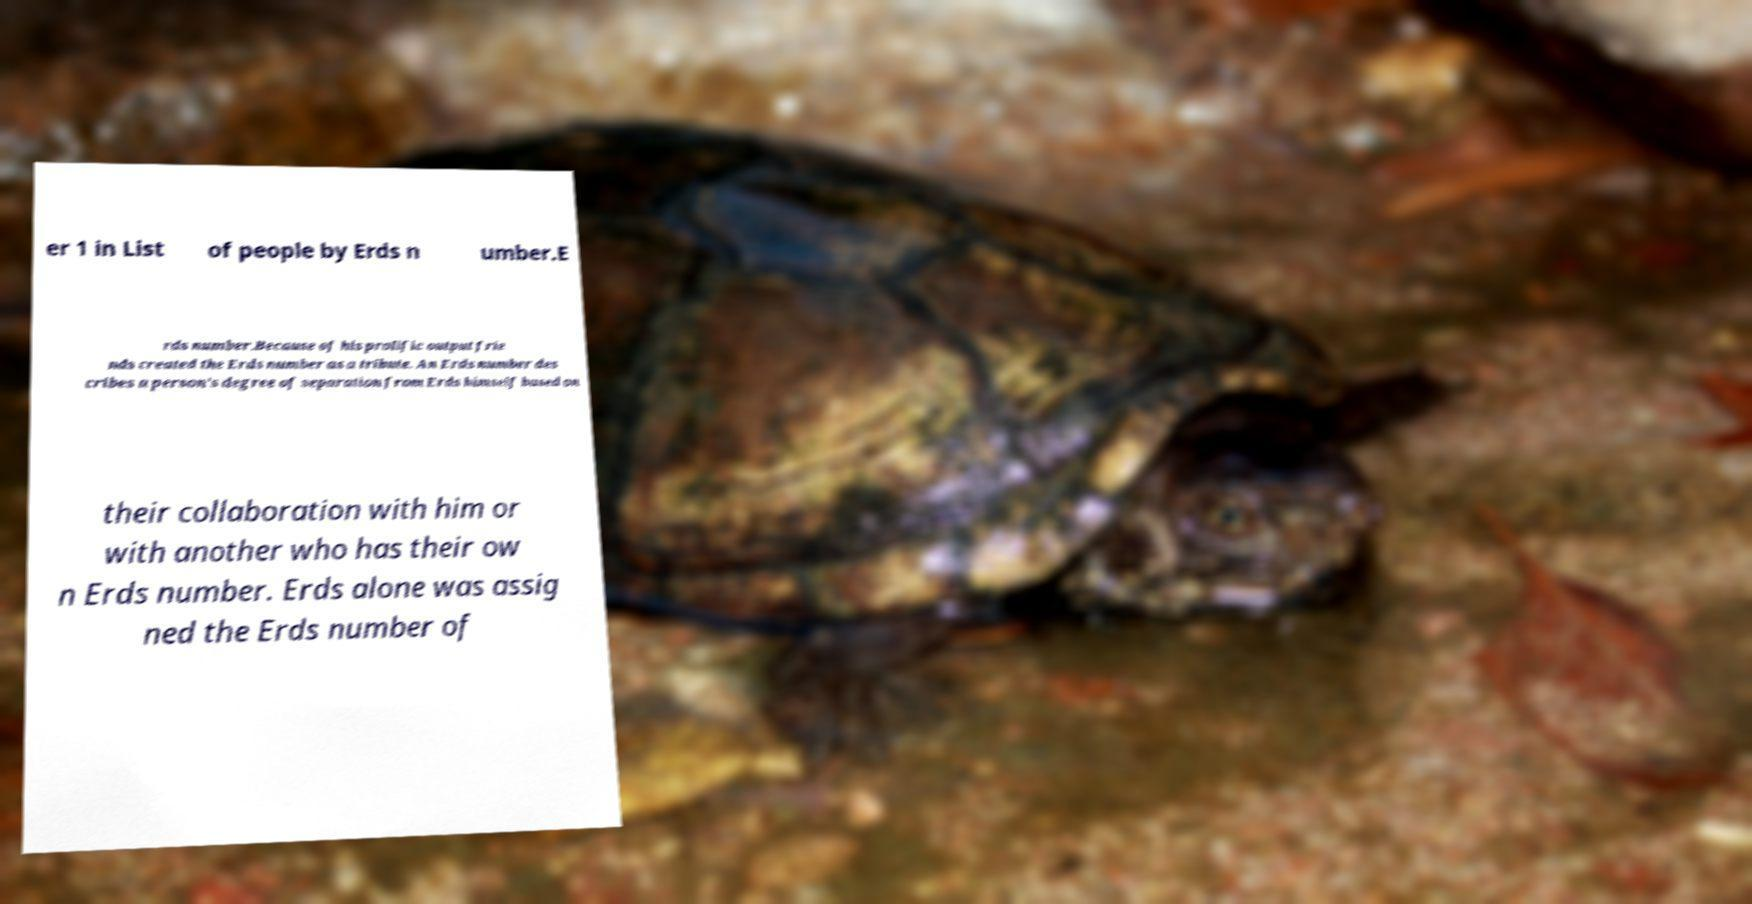I need the written content from this picture converted into text. Can you do that? er 1 in List of people by Erds n umber.E rds number.Because of his prolific output frie nds created the Erds number as a tribute. An Erds number des cribes a person's degree of separation from Erds himself based on their collaboration with him or with another who has their ow n Erds number. Erds alone was assig ned the Erds number of 